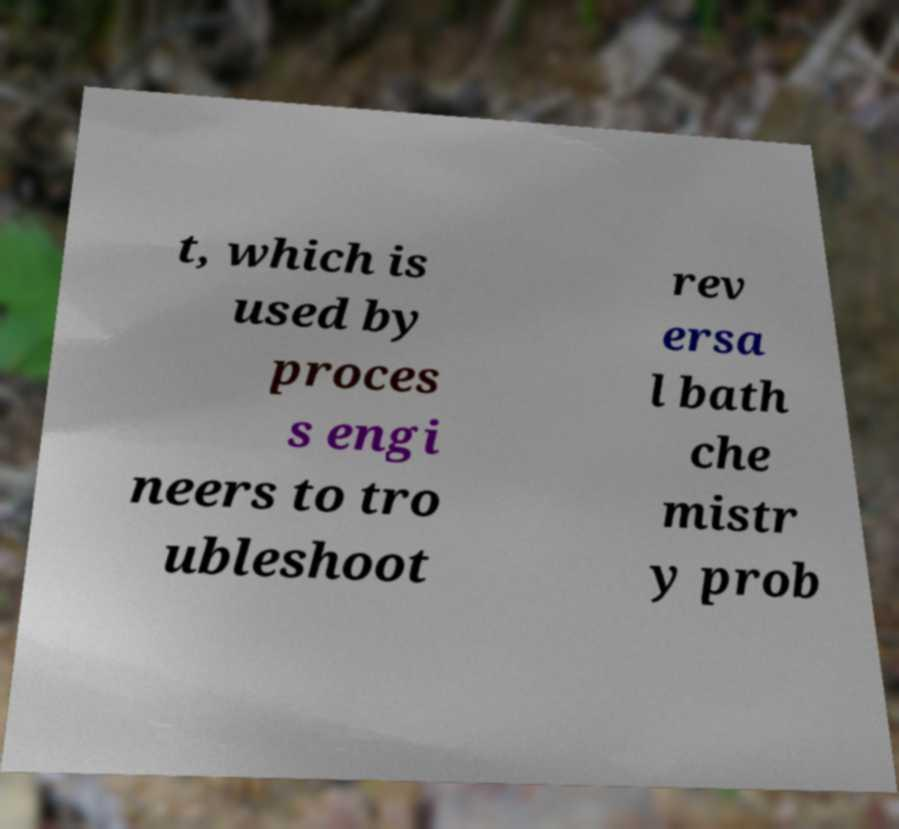Can you accurately transcribe the text from the provided image for me? t, which is used by proces s engi neers to tro ubleshoot rev ersa l bath che mistr y prob 